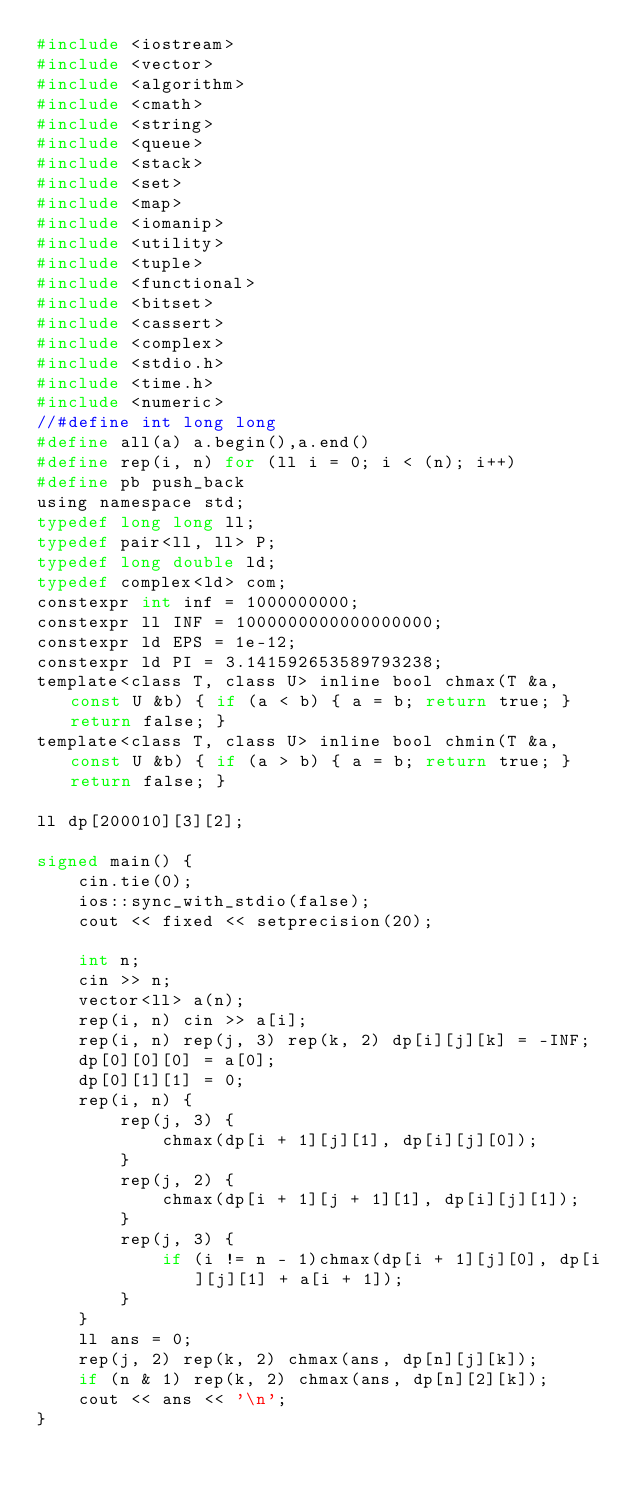<code> <loc_0><loc_0><loc_500><loc_500><_C_>#include <iostream>
#include <vector>
#include <algorithm>
#include <cmath>
#include <string>
#include <queue>
#include <stack>
#include <set>
#include <map>
#include <iomanip>
#include <utility>
#include <tuple>
#include <functional>
#include <bitset>
#include <cassert>
#include <complex>
#include <stdio.h>
#include <time.h>
#include <numeric>
//#define int long long
#define all(a) a.begin(),a.end()
#define rep(i, n) for (ll i = 0; i < (n); i++)
#define pb push_back
using namespace std;
typedef long long ll;
typedef pair<ll, ll> P;
typedef long double ld;
typedef complex<ld> com;
constexpr int inf = 1000000000;
constexpr ll INF = 1000000000000000000;
constexpr ld EPS = 1e-12;
constexpr ld PI = 3.141592653589793238;
template<class T, class U> inline bool chmax(T &a, const U &b) { if (a < b) { a = b; return true; } return false; }
template<class T, class U> inline bool chmin(T &a, const U &b) { if (a > b) { a = b; return true; } return false; }

ll dp[200010][3][2];

signed main() {
	cin.tie(0);
	ios::sync_with_stdio(false);
	cout << fixed << setprecision(20);

	int n;
	cin >> n;
	vector<ll> a(n);
	rep(i, n) cin >> a[i];
	rep(i, n) rep(j, 3) rep(k, 2) dp[i][j][k] = -INF;
	dp[0][0][0] = a[0];
	dp[0][1][1] = 0;
	rep(i, n) {
		rep(j, 3) {
			chmax(dp[i + 1][j][1], dp[i][j][0]);
		}
		rep(j, 2) {
			chmax(dp[i + 1][j + 1][1], dp[i][j][1]);
		}
		rep(j, 3) {
			if (i != n - 1)chmax(dp[i + 1][j][0], dp[i][j][1] + a[i + 1]);
		}
	}
	ll ans = 0;
	rep(j, 2) rep(k, 2) chmax(ans, dp[n][j][k]);
	if (n & 1) rep(k, 2) chmax(ans, dp[n][2][k]);
	cout << ans << '\n';
} </code> 